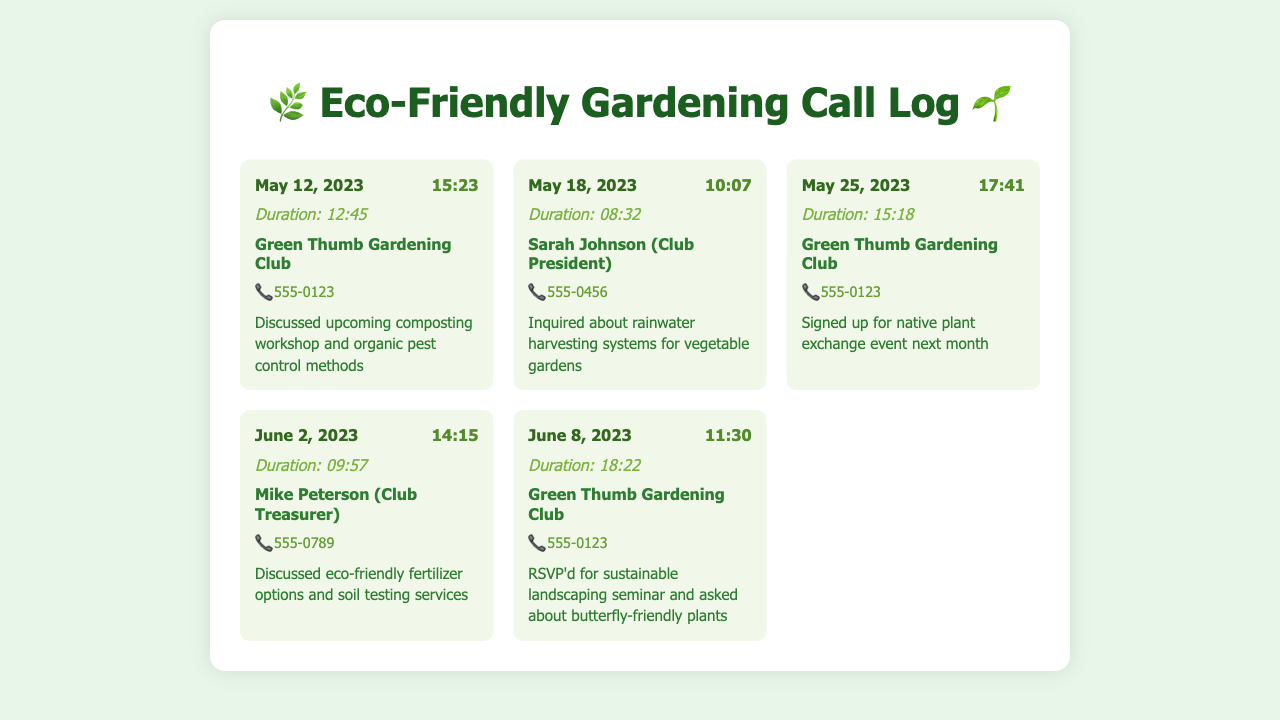What is the date of the composting workshop discussion? The date of the discussion regarding the composting workshop is found in the first call entry, which is May 12, 2023.
Answer: May 12, 2023 Who is the contact person for the rainwater harvesting inquiry? The inquiry about rainwater harvesting systems was made to Sarah Johnson, as noted in the second call entry.
Answer: Sarah Johnson What was discussed on June 8, 2023? The document states that on June 8, 2023, the caller RSVPd for a sustainable landscaping seminar and asked about butterfly-friendly plants.
Answer: Sustainable landscaping seminar, butterfly-friendly plants How long was the call with the Green Thumb Gardening Club on May 25, 2023? The duration of the call with the Green Thumb Gardening Club on May 25, 2023, is listed in the call entry as 15:18.
Answer: 15:18 Which call discussed eco-friendly fertilizer options? The discussion regarding eco-friendly fertilizer options took place in the call on June 2, 2023, with Mike Peterson.
Answer: June 2, 2023 What is the phone number for the Green Thumb Gardening Club? The phone number for the Green Thumb Gardening Club is provided in multiple entries, notably in the first and third call entries.
Answer: 555-0123 What kind of event was signed up for on May 25, 2023? The call on May 25, 2023, mentions signing up for a native plant exchange event, as recorded in the corresponding call entry.
Answer: Native plant exchange event 